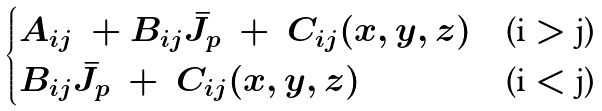Convert formula to latex. <formula><loc_0><loc_0><loc_500><loc_500>\begin{cases} { A _ { i j } } \ + { B _ { i j } } { \bar { J _ { p } } } \ + \ { C _ { i j } } ( x , y , z ) & \text {(i $>$ j)} \\ { B _ { i j } } { \bar { J _ { p } } } \ + \ { C _ { i j } } ( x , y , z ) & \text {(i $<$ j)} \end{cases}</formula> 